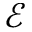<formula> <loc_0><loc_0><loc_500><loc_500>\mathcal { E }</formula> 